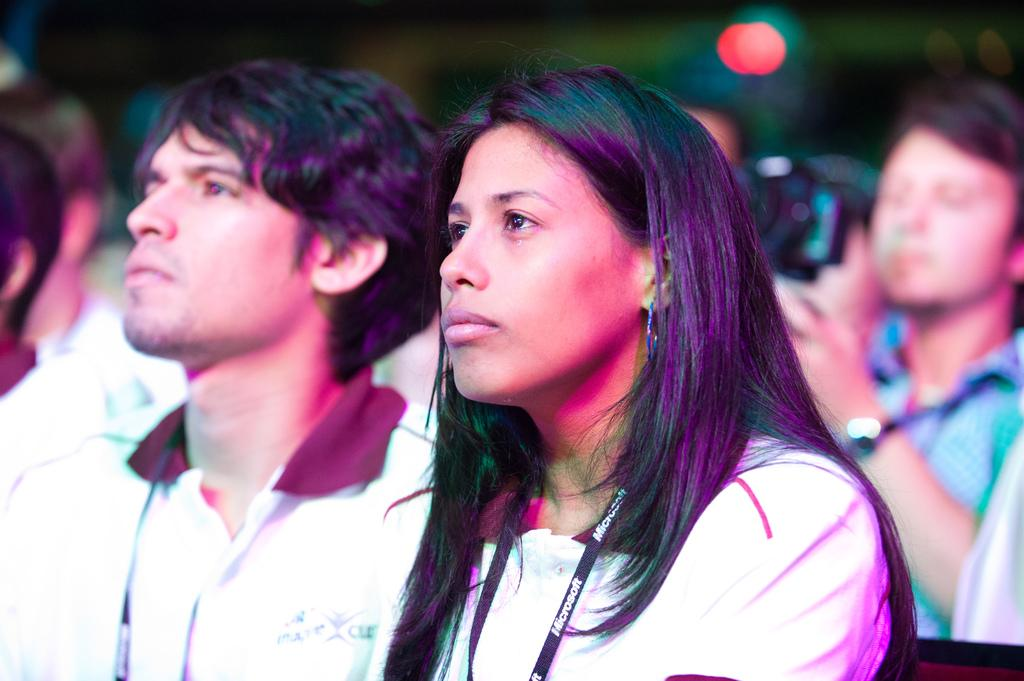How many people are sitting in the image? There are two people sitting in the image. What are the positions of the people in the image? One person is sitting in the center, and the other person is sitting on the right side. What is the person on the right side holding? The person on the right side is holding a camera. What type of hospital can be seen in the background of the image? There is no hospital visible in the image; it only features two people sitting. What discovery was made by the person on the left side of the image? There is no person on the left side of the image, and no discovery is mentioned or depicted. 